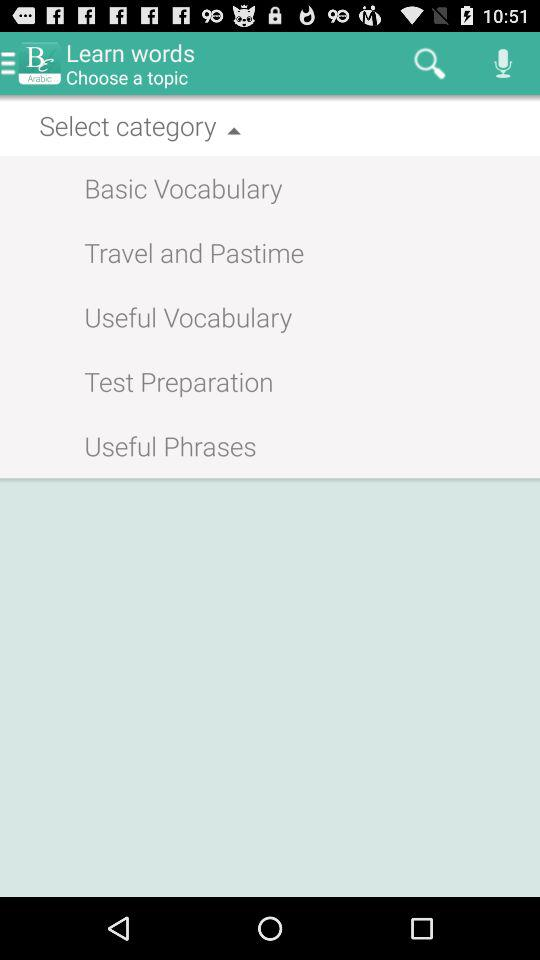What is the app's name? The app's name is "BC Arabic". 